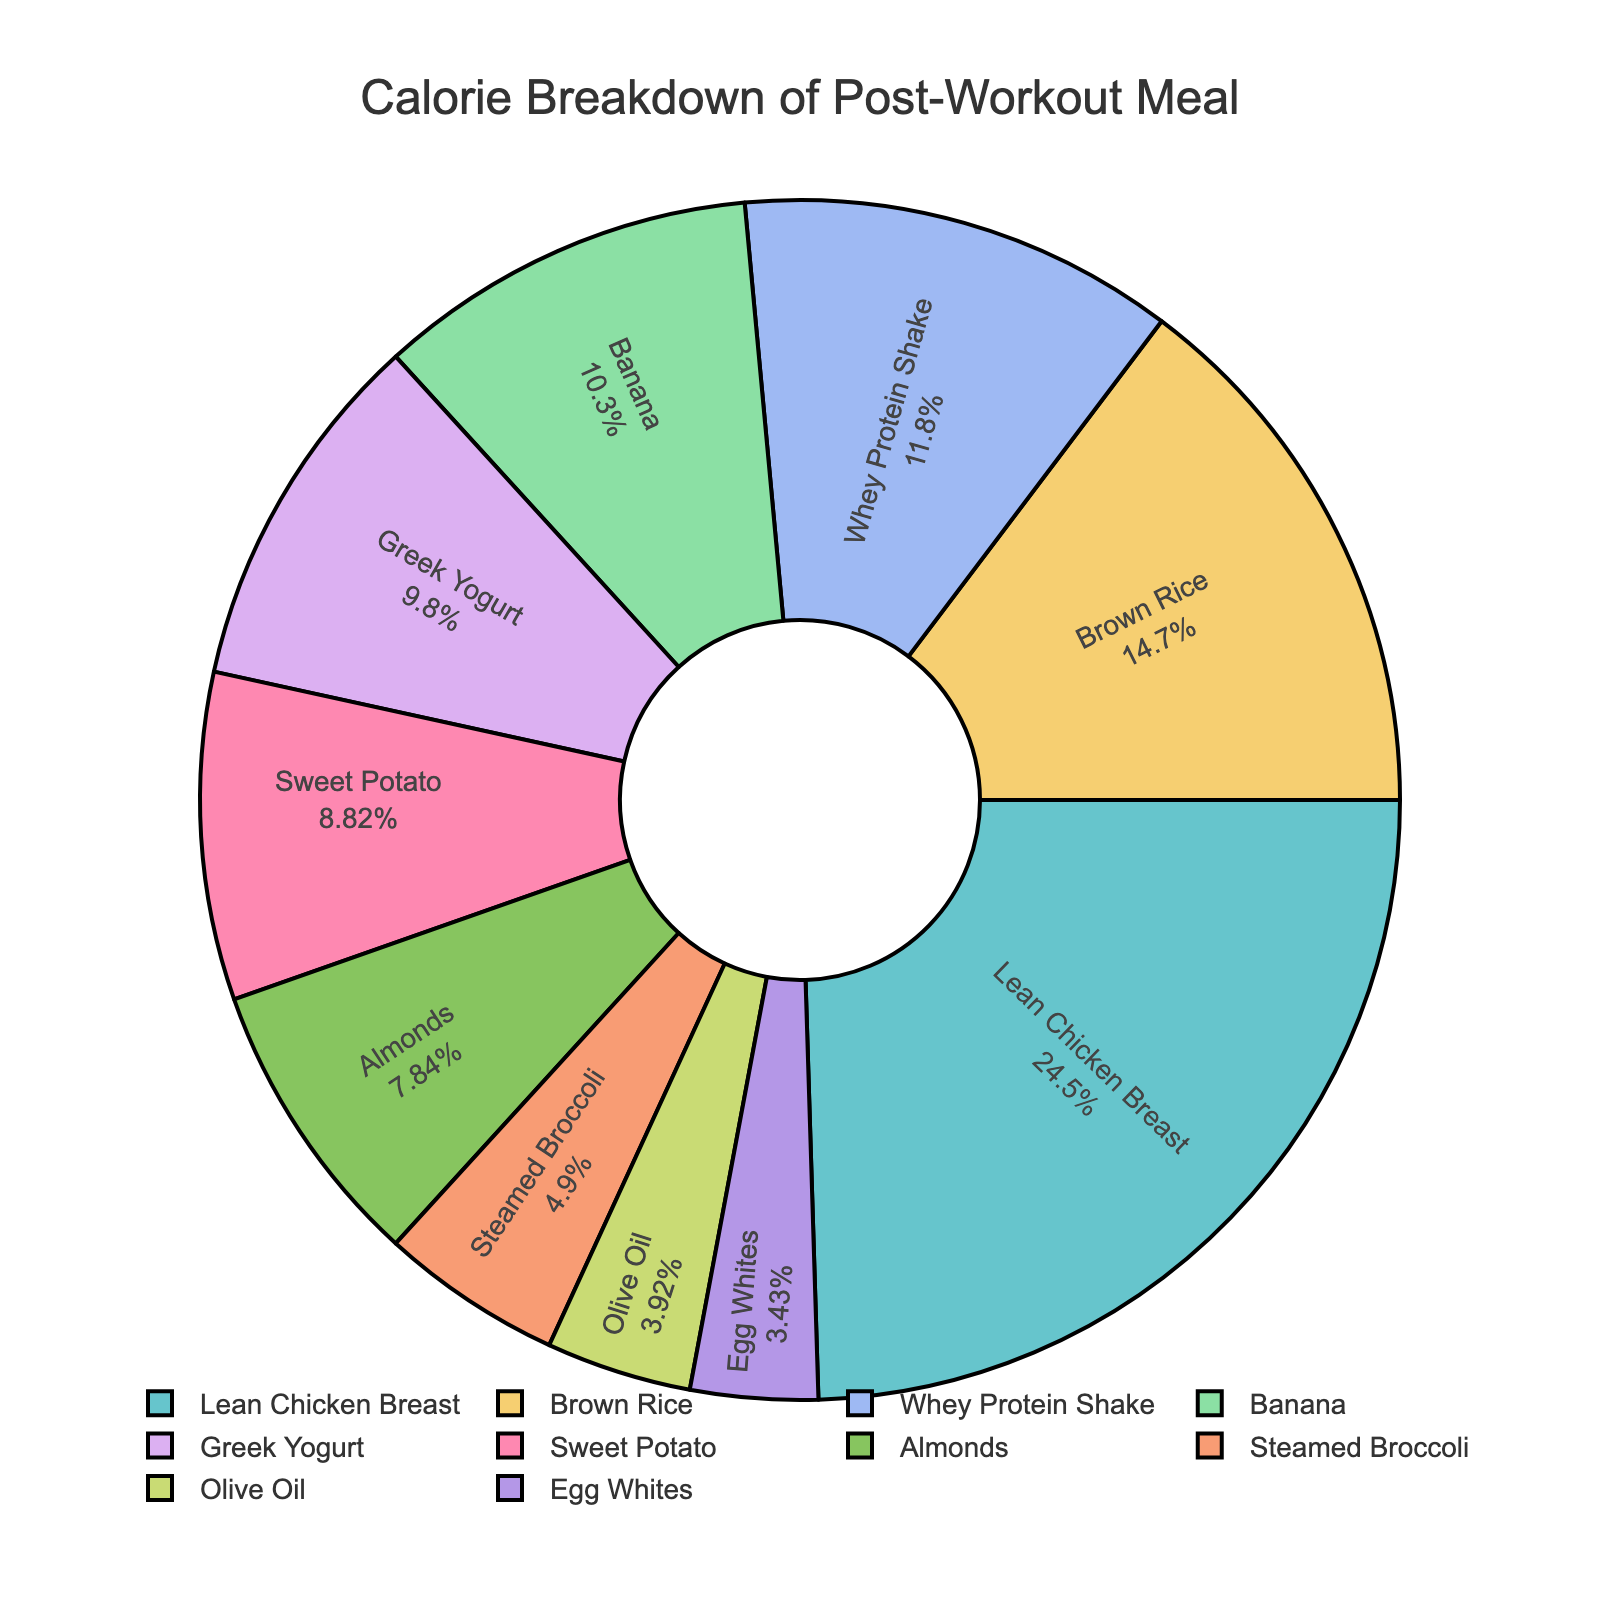What percentage of the total meal's calories comes from Lean Chicken Breast? The pie chart shows the calories from each nutrient and their respective percentages. Lean Chicken Breast contributes a specific percentage of the total calories displayed inside the chart.
Answer: 34% What's the combined calorie contribution of Almonds and Olive Oil? Sum the calorie values of Almonds (80 calories) and Olive Oil (40 calories) as shown in the chart. 80 + 40 = 120 calories.
Answer: 120 calories Which nutrient contributes more calories: Sweet Potato or Brown Rice? Compare the calorie values shown on the pie chart for Sweet Potato (90 calories) and Brown Rice (150 calories). Brown Rice has more calories.
Answer: Brown Rice What is the difference in calorie contribution between Greek Yogurt and Banana? Subtract the calories of Greek Yogurt (100 calories) from the calories of Banana (105 calories). 105 - 100 = 5 calories.
Answer: 5 calories Which nutrient has the smallest percentage contribution to the total calorie count? Identify the nutrient with the smallest percentage displayed on the pie chart. This will be Egg Whites with 2%.
Answer: Egg Whites Which two nutrients have a combined calorie contribution that equals the calories from Lean Chicken Breast? Identify two nutrients whose total equals Lean Chicken Breast's (250 calories). Whey Protein Shake (120 calories) and Sweet Potato (90 calories) combine to make 210 calories, add another nutrient such as Egg Whites (35 calories) to reach close to 250.
Answer: Whey Protein Shake and Sweet Potato How does the calorie contribution of Whey Protein Shake compare to that of Greek Yogurt? Compare the numerical values of calories from Whey Protein Shake (120 calories) and Greek Yogurt (100 calories). Whey Protein Shake has more calories.
Answer: Whey Protein Shake What is the average calorie contribution from the three highest-calorie items? Identify the three highest-calorie items: Lean Chicken Breast (250), Brown Rice (150), and Banana (105). Calculate their average by summing these and dividing by three. (250 + 150 + 105) / 3 = 505 / 3 = 168.33
Answer: 168.33 What percentage of the meal's calories come from vegetables (Steamed Broccoli and Sweet Potato)? Add the calorie percentages for Steamed Broccoli and Sweet Potato displayed on the chart. If Steamed Broccoli is 7% and Sweet Potato is 12%, then the combined percentage is 7% + 12% = 19%.
Answer: 19% 